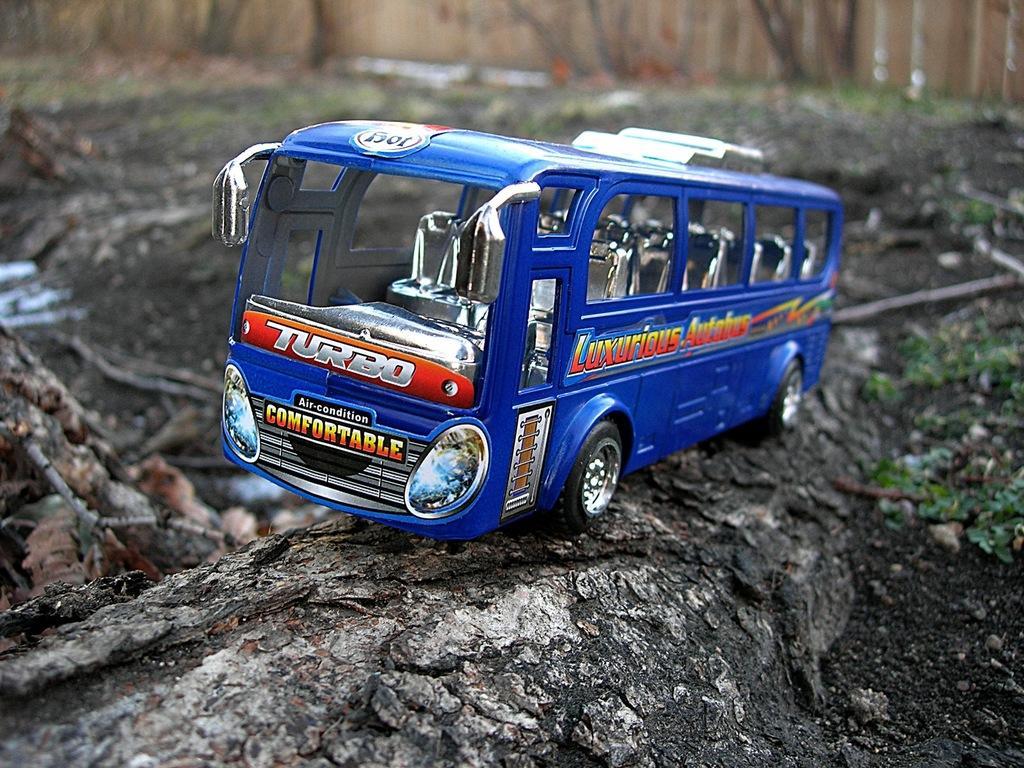How would you summarize this image in a sentence or two? In the center of the image we can see a toy vehicle is present on the ground. In the background of the image we can see dry leaves, rock, grass. At the top of the image we can see the trees. 